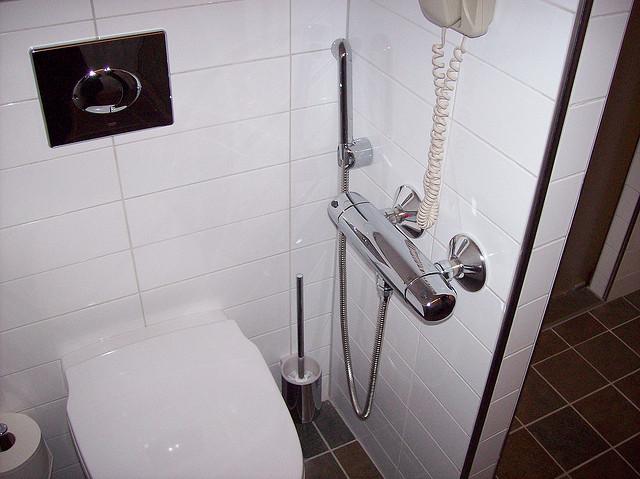Is there a phone near the toilet?
Give a very brief answer. Yes. What is the object standing beside the toilet called?
Be succinct. Plunger. How do you flush this toilet?
Quick response, please. Push button. 